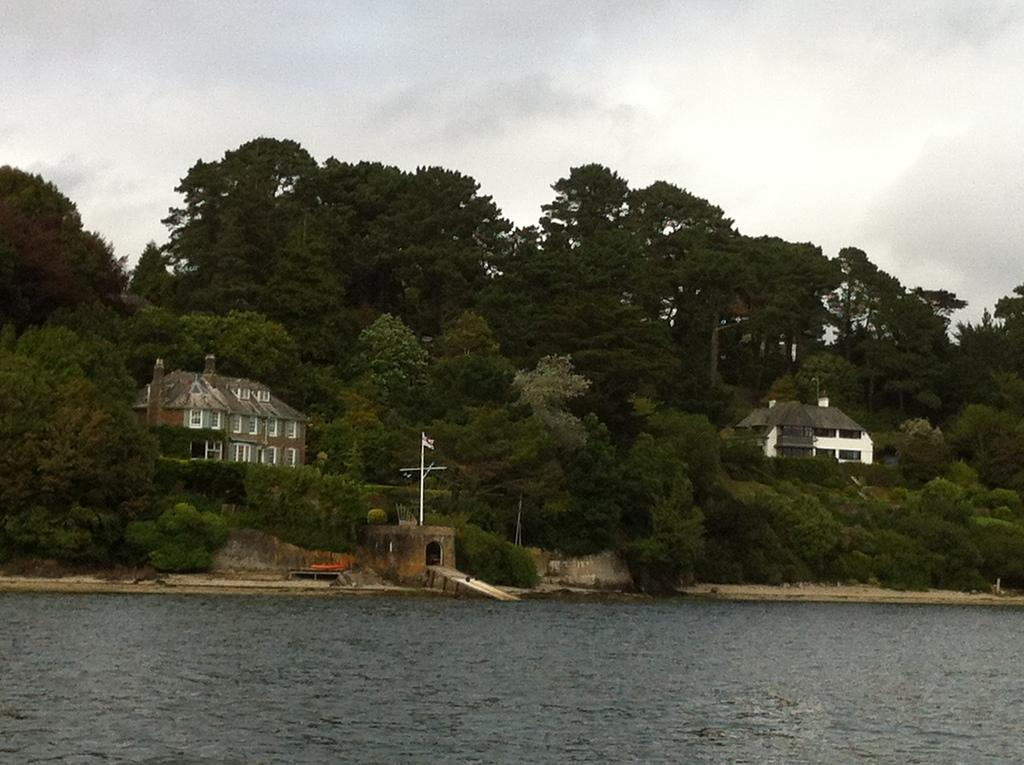What natural feature is the main subject of the image? There is a river in the image. What can be seen behind the river? There is a lot of greenery behind the river. Are there any man-made structures visible in the image? Yes, there are two houses between the trees. What is visible in the background of the image? The sky is visible in the background of the image. What type of quilt is being used by the visitor in the image? There is no quilt or visitor present in the image; it features a river, greenery, houses, and the sky. 